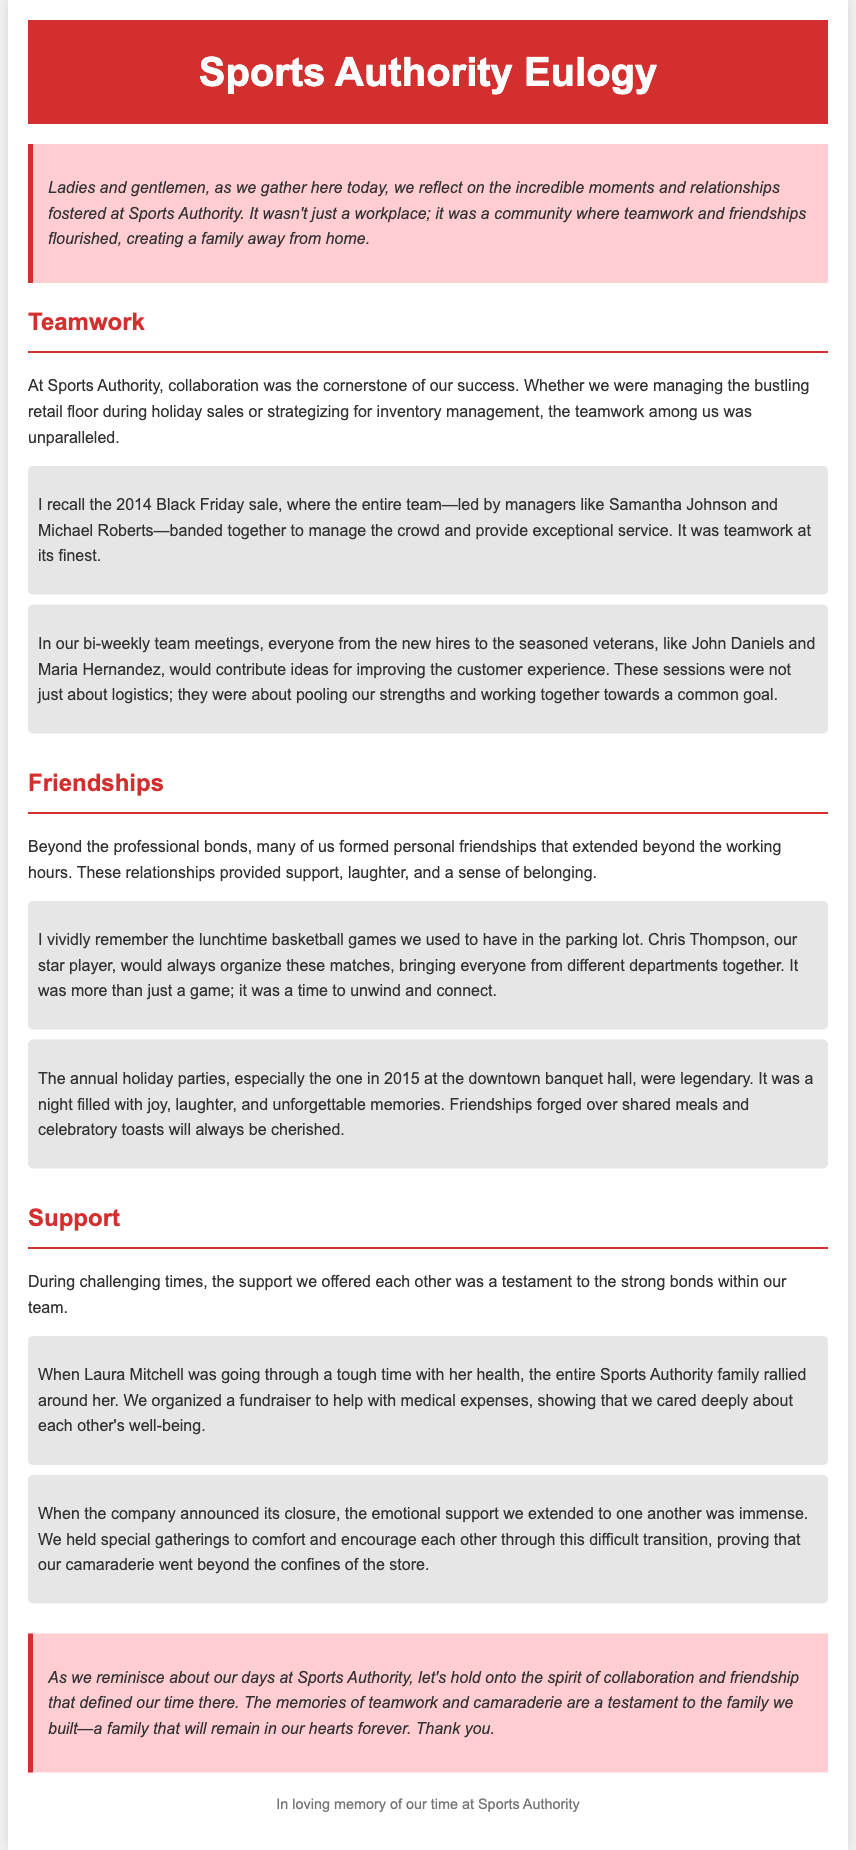what was the cornerstone of success at Sports Authority? The document states that collaboration was the cornerstone of success at Sports Authority.
Answer: collaboration who organized the lunchtime basketball games? The document mentions that Chris Thompson organized the lunchtime basketball games.
Answer: Chris Thompson in what year was the Black Friday sale mentioned? The document refers to the 2014 Black Friday sale.
Answer: 2014 what was a significant event where the team provided support to Laura Mitchell? The document highlights that the team organized a fundraiser to help Laura Mitchell with medical expenses.
Answer: fundraiser what did the emotional support during the company's closure symbolize? The document indicates that the emotional support symbolized the camaraderie that went beyond the confines of the store.
Answer: camaraderie what is noted as a legendary event in 2015? The document refers to the annual holiday party in 2015 as legendary.
Answer: holiday party which managers led the team during the Black Friday sale? The document states that Samantha Johnson and Michael Roberts led the team during the Black Friday sale.
Answer: Samantha Johnson and Michael Roberts how did the team come together during challenging times? The document emphasizes that the support offered during challenging times was a testament to the strong bonds within the team.
Answer: strong bonds what type of document is this? The document is a eulogy celebrating teamwork and friendships built at Sports Authority.
Answer: eulogy 